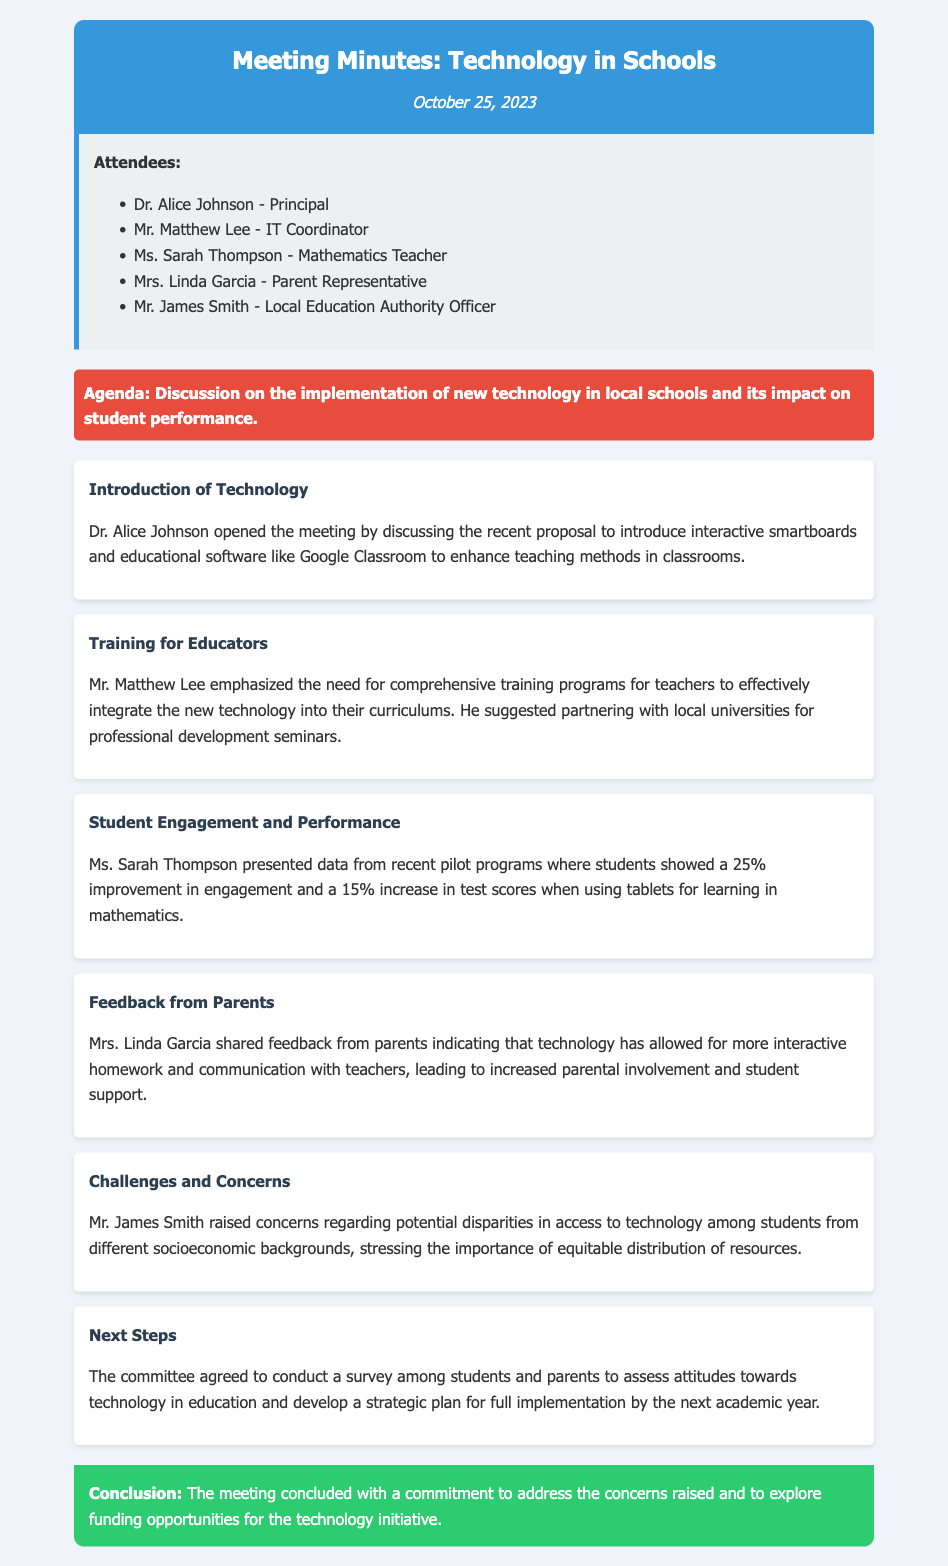what is the date of the meeting? The date of the meeting is mentioned in the header of the document.
Answer: October 25, 2023 who is the principal? The principal's name is listed in the attendees section.
Answer: Dr. Alice Johnson what technology is being proposed for schools? The proposal details can be found in the introduction of technology section.
Answer: Interactive smartboards and educational software what was the improvement in student engagement? The improvement is provided in the discussion of student engagement and performance.
Answer: 25% who provided feedback from parents? The name of the attendee who shared feedback is noted in the document.
Answer: Mrs. Linda Garcia what concern did Mr. James Smith raise? The document states Mr. James Smith's concern regarding disparities, which is discussed in a specific section.
Answer: Disparities in access to technology what is the purpose of the upcoming survey? The purpose is mentioned in the next steps section of the meeting minutes.
Answer: Assess attitudes towards technology in education which committee member suggested partnering with local universities for training? The document identifies the member making this suggestion in the relevant section.
Answer: Mr. Matthew Lee 